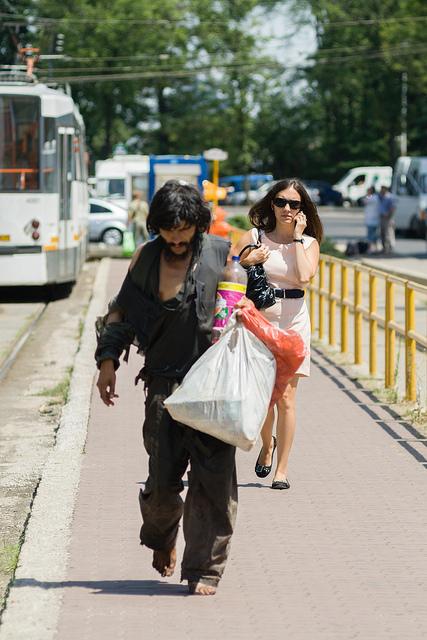Do you see lots of people?
Quick response, please. No. What is the woman in white doing as she walks down the street?
Give a very brief answer. Talking on phone. Are the people together?
Write a very short answer. No. What color is the man's vest?
Answer briefly. Black. Is the photo in color?
Be succinct. Yes. What is the women holding?
Keep it brief. Phone. How many people in this scene aren't wearing shoes?
Quick response, please. 1. 